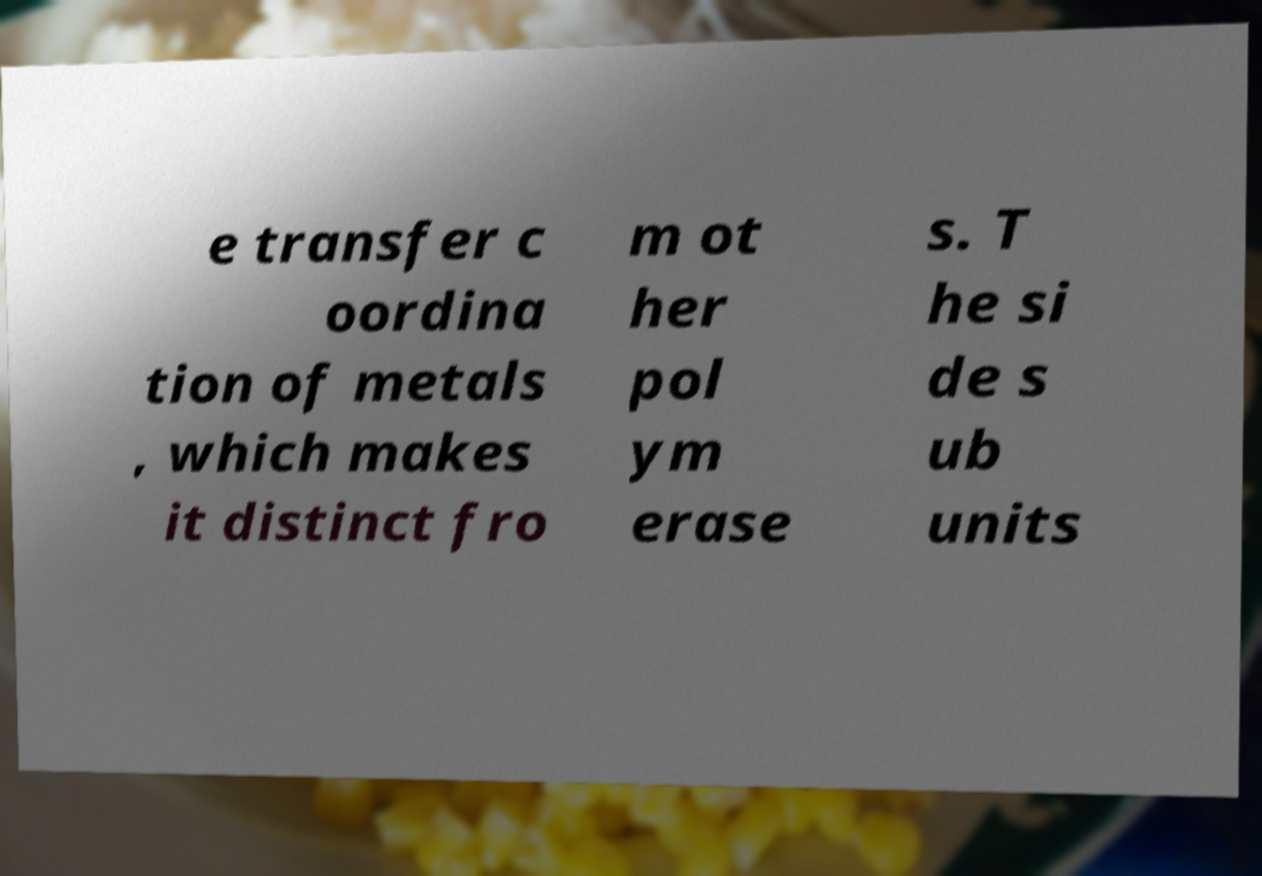Can you accurately transcribe the text from the provided image for me? e transfer c oordina tion of metals , which makes it distinct fro m ot her pol ym erase s. T he si de s ub units 